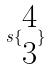<formula> <loc_0><loc_0><loc_500><loc_500>s \{ \begin{matrix} 4 \\ 3 \end{matrix} \}</formula> 